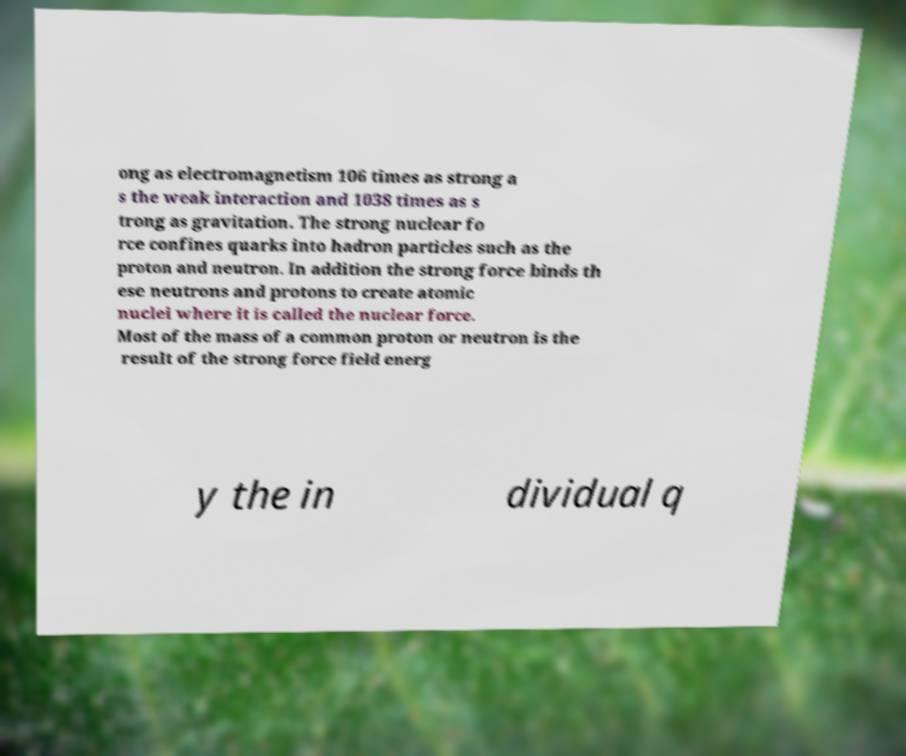Could you assist in decoding the text presented in this image and type it out clearly? ong as electromagnetism 106 times as strong a s the weak interaction and 1038 times as s trong as gravitation. The strong nuclear fo rce confines quarks into hadron particles such as the proton and neutron. In addition the strong force binds th ese neutrons and protons to create atomic nuclei where it is called the nuclear force. Most of the mass of a common proton or neutron is the result of the strong force field energ y the in dividual q 